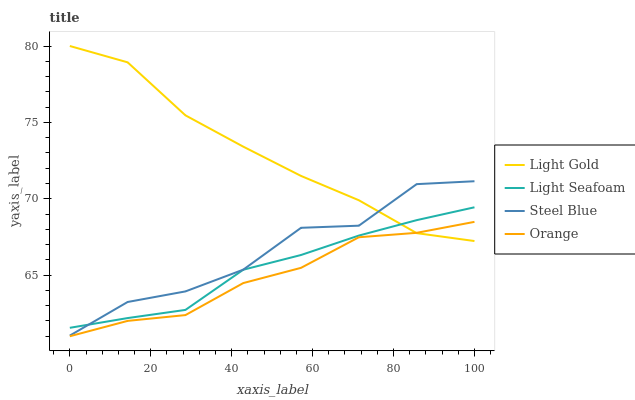Does Orange have the minimum area under the curve?
Answer yes or no. Yes. Does Light Gold have the maximum area under the curve?
Answer yes or no. Yes. Does Light Seafoam have the minimum area under the curve?
Answer yes or no. No. Does Light Seafoam have the maximum area under the curve?
Answer yes or no. No. Is Light Seafoam the smoothest?
Answer yes or no. Yes. Is Steel Blue the roughest?
Answer yes or no. Yes. Is Light Gold the smoothest?
Answer yes or no. No. Is Light Gold the roughest?
Answer yes or no. No. Does Orange have the lowest value?
Answer yes or no. Yes. Does Light Seafoam have the lowest value?
Answer yes or no. No. Does Light Gold have the highest value?
Answer yes or no. Yes. Does Light Seafoam have the highest value?
Answer yes or no. No. Is Orange less than Steel Blue?
Answer yes or no. Yes. Is Light Seafoam greater than Orange?
Answer yes or no. Yes. Does Light Seafoam intersect Steel Blue?
Answer yes or no. Yes. Is Light Seafoam less than Steel Blue?
Answer yes or no. No. Is Light Seafoam greater than Steel Blue?
Answer yes or no. No. Does Orange intersect Steel Blue?
Answer yes or no. No. 